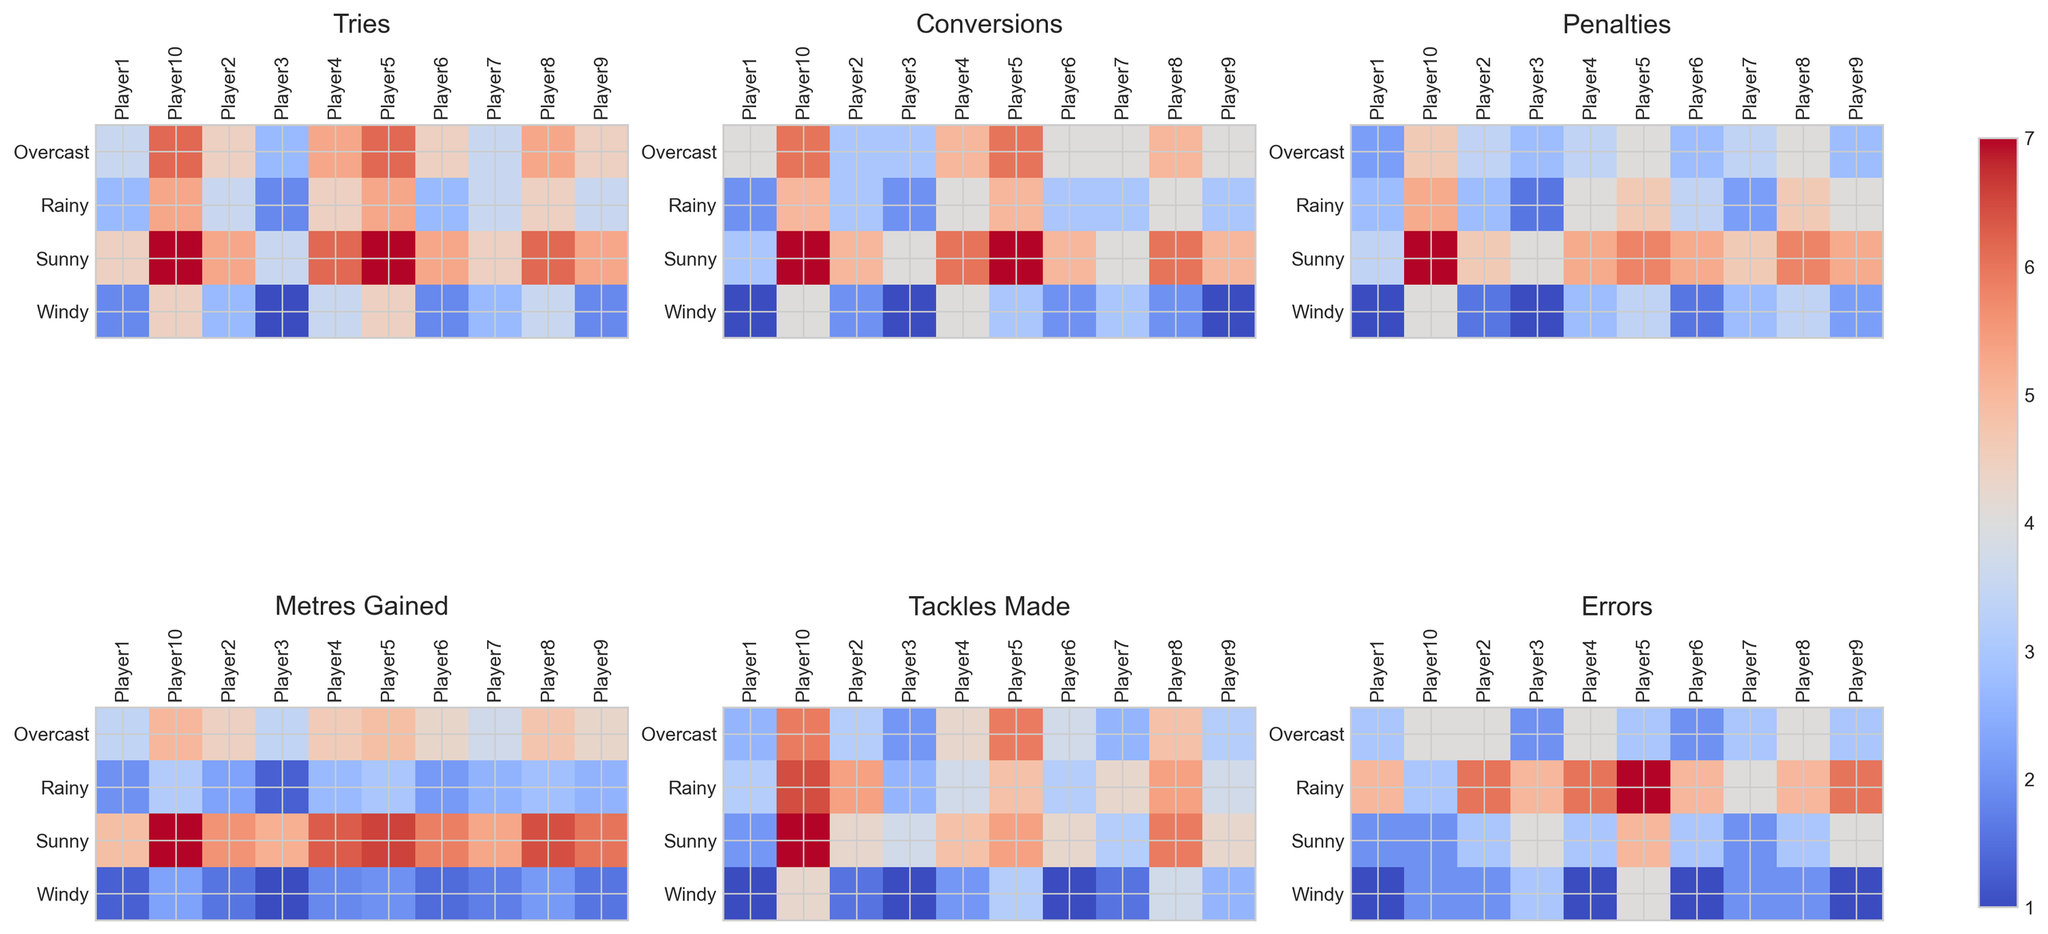What weather condition has the highest number of tries for Player1? Look at the heatmap for Player1 under the 'Tries' metric. Identify which row corresponding to a weather condition has the highest visual intensity/color.
Answer: Sunny What is the average number of tackles made by Player5 across all weather conditions? Find the heatmap for Player5 under the 'Tackles Made' metric. Note the values for Sunny, Rainy, Overcast, and Windy. Sum these values and divide by the number of conditions (4).
Answer: 25 (26+25+27+22)=100, 100/4 = 25 Which weather condition shows the maximum errors for Player10? Check the 'Errors' heatmap for Player10. Identify the weather condition with the most intense color corresponding to the highest errors number.
Answer: Rainy How many more conversions does Player4 make in Sunny versus Windy weather? Refer to the 'Conversions' heatmap for Player4. Note the values in Sunny and Windy. Subtract the Windy value from the Sunny value.
Answer: 6-4 = 2 Which player gains the most metres in Overcast weather? Look at the 'Metres Gained' heatmap for Overcast weather across all players. Identify the player with the most intense color indicating the highest value.
Answer: Player10 In which weather condition does Player2 make fewer tackles: Rainy or Sunny? Refer to the 'Tackles Made' heatmap for Player2. Compare the values for Rainy and Sunny conditions.
Answer: Sunny How many penalties does Player7 make on average in Rainy and Windy conditions? Check the heatmap for Player7 under the 'Penalties' metric. Check the values for Rainy and Windy. Sum these values and divide by 2.
Answer: (4+5)=9, 9/2 = 4.5 What is the difference in metres gained between Sunny and Overcast conditions for Player6? Look at the 'Metres Gained' heatmap for Player6. Note the values for Sunny and Overcast. Subtract the Overcast value from the Sunny value.
Answer: 570-460 = 110 Does Player3 make more tries in Overcast or Rainy weather? Check the 'Tries' heatmap for Player3. Compare the values for Overcast and Rainy conditions.
Answer: Overcast Which weather condition shows the least number of conversions for Player9? Observe the heatmap for Player9 under the 'Conversions' metric. Identify the weather condition with the least intense color indicating the lowest value.
Answer: Windy 